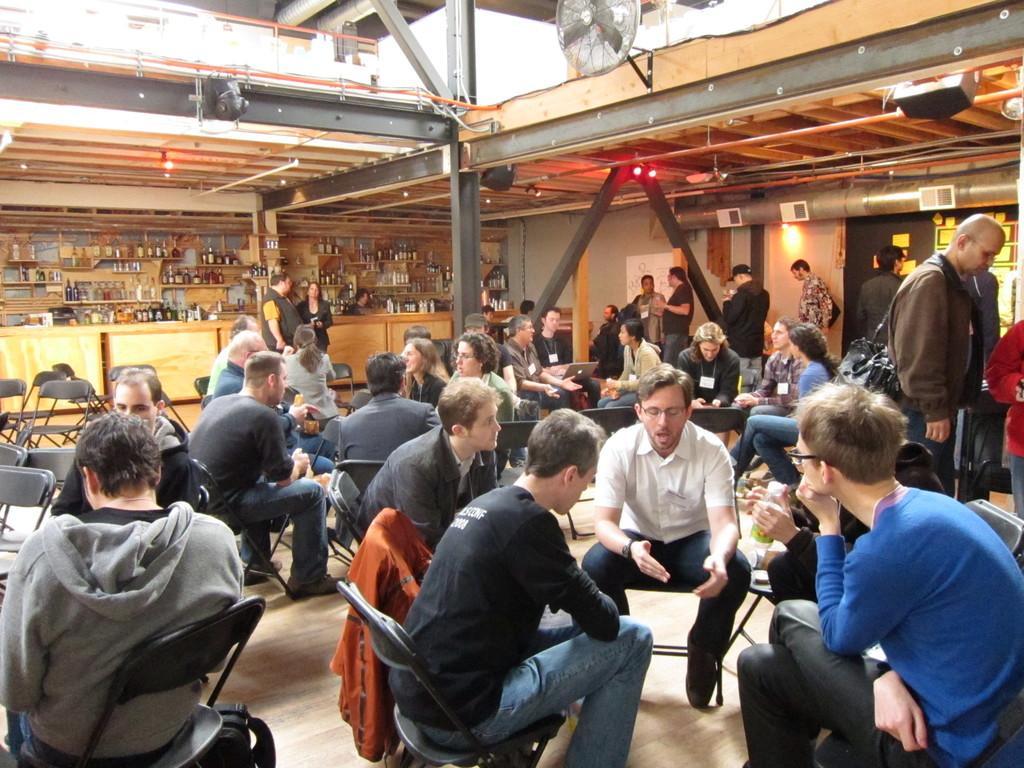How would you summarize this image in a sentence or two? In this picture I can see number of people in which most of them are sitting on chairs and rest of them are standing. On the left side of this image I can see few empty chairs. In the background I can see number of bottles on the racks. On the top of this picture I can see the ceiling on which there are few lights and I can see a fan and I see few rods. 